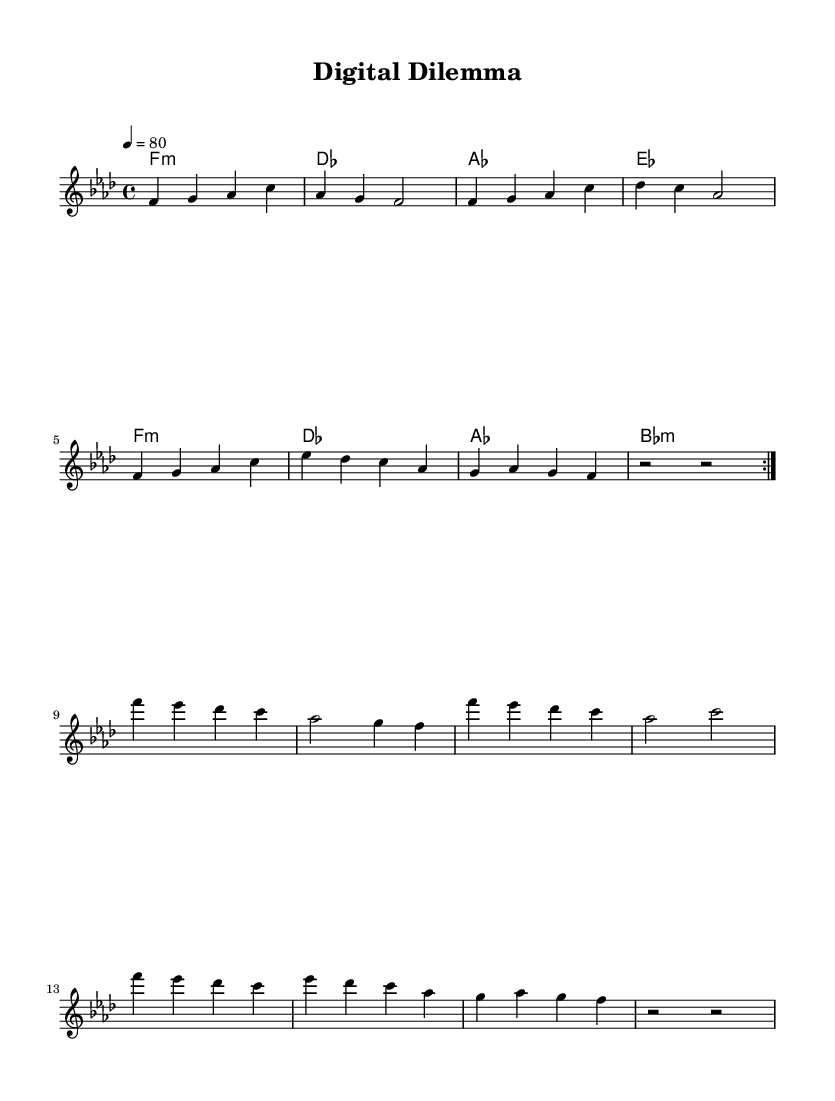What is the key signature of this music? The key signature is indicated by the "f" symbol, which signifies F minor, as noted in the global section of the code.
Answer: F minor What is the time signature of this music? The time signature is shown as "4/4" at the beginning of the score, indicating four beats per measure and a quarter note gets one beat.
Answer: 4/4 What is the tempo marking for this piece? The tempo is specified as "4 = 80" in the global section, which means the quarter note gets 80 beats per minute.
Answer: 80 How many measures are in the melody section? Counting the measures noted in the melody, there are a total of 12 measures as indicated by the repeated sections and their lengths.
Answer: 12 What chord does the music begin with? The music starts with the chord indicated as "f1:m" in the harmonies section, meaning it is an F minor chord.
Answer: F minor What is the last chord of the harmonies section? The last chord is indicated as "bes:m", representing a B flat minor chord as per the provided chord progression.
Answer: B flat minor What rhythmic pattern is predominantly used in the melody? The melody predominantly utilizes quarter notes and half notes, organized into consistent rhythmic patterns following the 4/4 time signature.
Answer: Quarter and half notes 